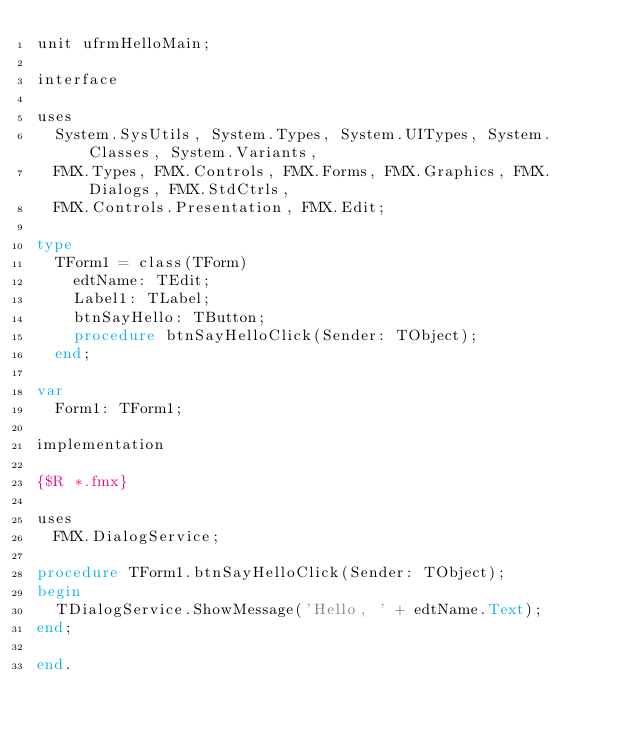<code> <loc_0><loc_0><loc_500><loc_500><_Pascal_>unit ufrmHelloMain;

interface

uses
  System.SysUtils, System.Types, System.UITypes, System.Classes, System.Variants,
  FMX.Types, FMX.Controls, FMX.Forms, FMX.Graphics, FMX.Dialogs, FMX.StdCtrls,
  FMX.Controls.Presentation, FMX.Edit;

type
  TForm1 = class(TForm)
    edtName: TEdit;
    Label1: TLabel;
    btnSayHello: TButton;
    procedure btnSayHelloClick(Sender: TObject);
  end;

var
  Form1: TForm1;

implementation

{$R *.fmx}

uses
  FMX.DialogService;

procedure TForm1.btnSayHelloClick(Sender: TObject);
begin
  TDialogService.ShowMessage('Hello, ' + edtName.Text);
end;

end.
</code> 